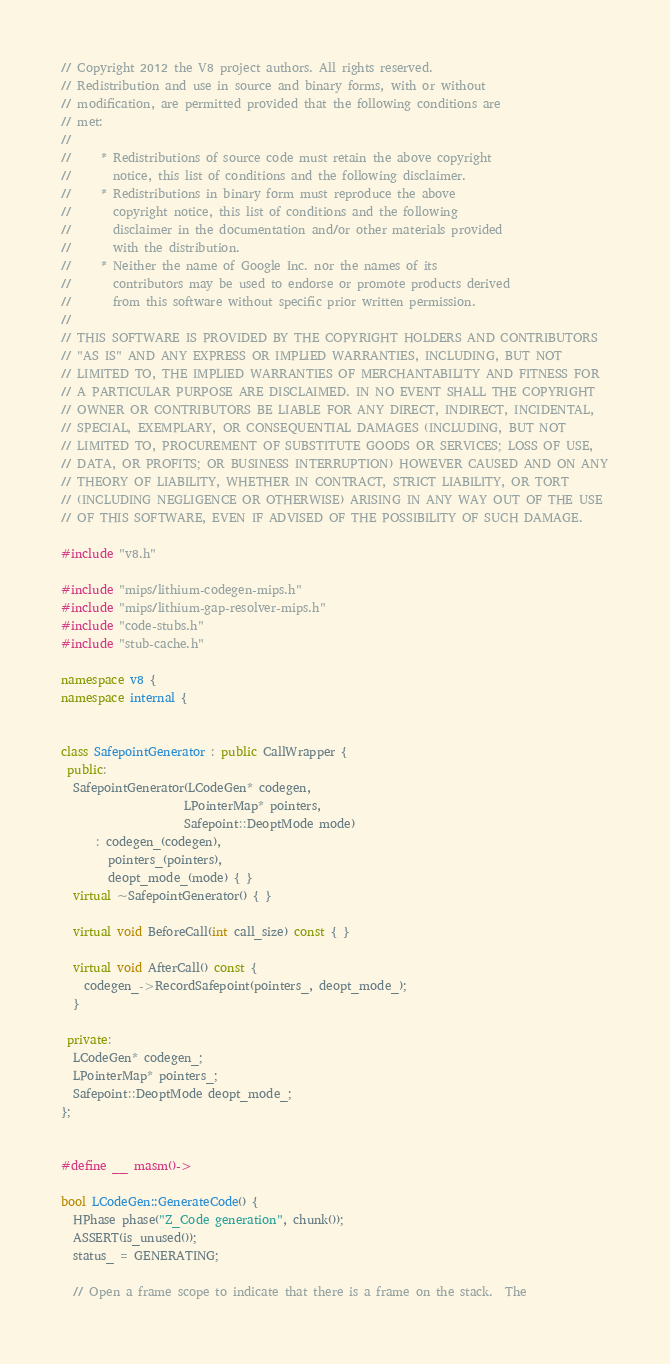Convert code to text. <code><loc_0><loc_0><loc_500><loc_500><_C++_>// Copyright 2012 the V8 project authors. All rights reserved.
// Redistribution and use in source and binary forms, with or without
// modification, are permitted provided that the following conditions are
// met:
//
//     * Redistributions of source code must retain the above copyright
//       notice, this list of conditions and the following disclaimer.
//     * Redistributions in binary form must reproduce the above
//       copyright notice, this list of conditions and the following
//       disclaimer in the documentation and/or other materials provided
//       with the distribution.
//     * Neither the name of Google Inc. nor the names of its
//       contributors may be used to endorse or promote products derived
//       from this software without specific prior written permission.
//
// THIS SOFTWARE IS PROVIDED BY THE COPYRIGHT HOLDERS AND CONTRIBUTORS
// "AS IS" AND ANY EXPRESS OR IMPLIED WARRANTIES, INCLUDING, BUT NOT
// LIMITED TO, THE IMPLIED WARRANTIES OF MERCHANTABILITY AND FITNESS FOR
// A PARTICULAR PURPOSE ARE DISCLAIMED. IN NO EVENT SHALL THE COPYRIGHT
// OWNER OR CONTRIBUTORS BE LIABLE FOR ANY DIRECT, INDIRECT, INCIDENTAL,
// SPECIAL, EXEMPLARY, OR CONSEQUENTIAL DAMAGES (INCLUDING, BUT NOT
// LIMITED TO, PROCUREMENT OF SUBSTITUTE GOODS OR SERVICES; LOSS OF USE,
// DATA, OR PROFITS; OR BUSINESS INTERRUPTION) HOWEVER CAUSED AND ON ANY
// THEORY OF LIABILITY, WHETHER IN CONTRACT, STRICT LIABILITY, OR TORT
// (INCLUDING NEGLIGENCE OR OTHERWISE) ARISING IN ANY WAY OUT OF THE USE
// OF THIS SOFTWARE, EVEN IF ADVISED OF THE POSSIBILITY OF SUCH DAMAGE.

#include "v8.h"

#include "mips/lithium-codegen-mips.h"
#include "mips/lithium-gap-resolver-mips.h"
#include "code-stubs.h"
#include "stub-cache.h"

namespace v8 {
namespace internal {


class SafepointGenerator : public CallWrapper {
 public:
  SafepointGenerator(LCodeGen* codegen,
                     LPointerMap* pointers,
                     Safepoint::DeoptMode mode)
      : codegen_(codegen),
        pointers_(pointers),
        deopt_mode_(mode) { }
  virtual ~SafepointGenerator() { }

  virtual void BeforeCall(int call_size) const { }

  virtual void AfterCall() const {
    codegen_->RecordSafepoint(pointers_, deopt_mode_);
  }

 private:
  LCodeGen* codegen_;
  LPointerMap* pointers_;
  Safepoint::DeoptMode deopt_mode_;
};


#define __ masm()->

bool LCodeGen::GenerateCode() {
  HPhase phase("Z_Code generation", chunk());
  ASSERT(is_unused());
  status_ = GENERATING;

  // Open a frame scope to indicate that there is a frame on the stack.  The</code> 